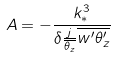Convert formula to latex. <formula><loc_0><loc_0><loc_500><loc_500>A = - \frac { k _ { * } ^ { 3 } } { \delta \frac { j } { \overline { \theta _ { z } } } \overline { w ^ { \prime } \theta _ { z } ^ { \prime } } }</formula> 